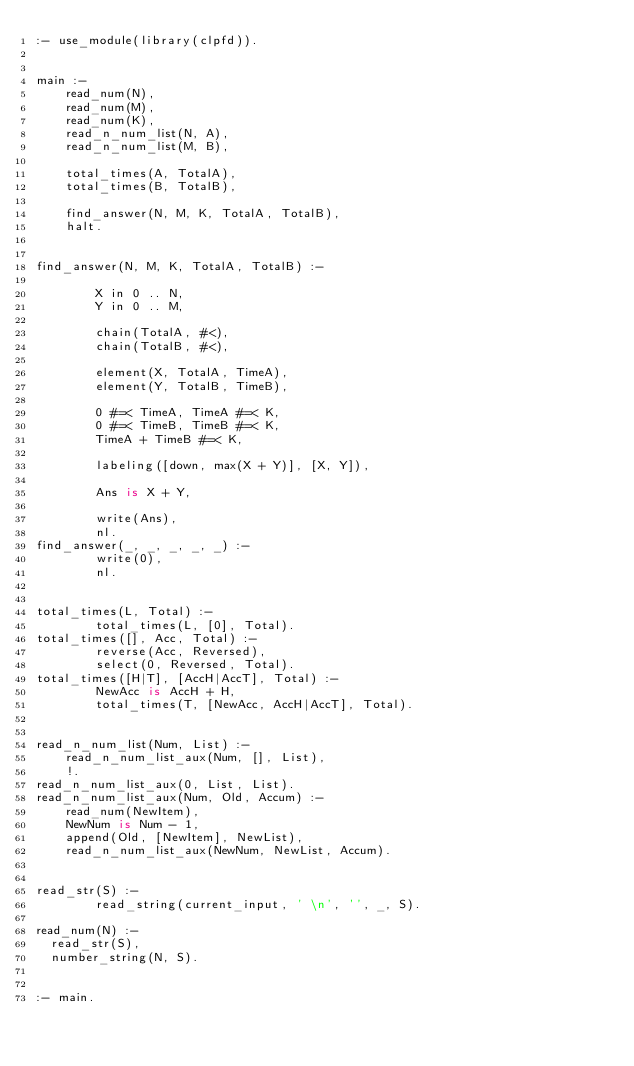<code> <loc_0><loc_0><loc_500><loc_500><_Prolog_>:- use_module(library(clpfd)).


main :-
    read_num(N),
    read_num(M),
    read_num(K),
    read_n_num_list(N, A),
    read_n_num_list(M, B),

    total_times(A, TotalA),
    total_times(B, TotalB),

    find_answer(N, M, K, TotalA, TotalB),
    halt.


find_answer(N, M, K, TotalA, TotalB) :-

        X in 0 .. N,
        Y in 0 .. M,

        chain(TotalA, #<),
        chain(TotalB, #<),
        
        element(X, TotalA, TimeA),
        element(Y, TotalB, TimeB),
        
        0 #=< TimeA, TimeA #=< K,
        0 #=< TimeB, TimeB #=< K,
        TimeA + TimeB #=< K,

        labeling([down, max(X + Y)], [X, Y]),

        Ans is X + Y,

        write(Ans),
        nl.
find_answer(_, _, _, _, _) :-
        write(0),
        nl.


total_times(L, Total) :-
        total_times(L, [0], Total).
total_times([], Acc, Total) :-
        reverse(Acc, Reversed),
        select(0, Reversed, Total).
total_times([H|T], [AccH|AccT], Total) :-
        NewAcc is AccH + H,
        total_times(T, [NewAcc, AccH|AccT], Total).


read_n_num_list(Num, List) :-
    read_n_num_list_aux(Num, [], List),
    !.
read_n_num_list_aux(0, List, List).
read_n_num_list_aux(Num, Old, Accum) :-
    read_num(NewItem),
    NewNum is Num - 1,
    append(Old, [NewItem], NewList),
    read_n_num_list_aux(NewNum, NewList, Accum).


read_str(S) :-
        read_string(current_input, ' \n', '', _, S).
 
read_num(N) :-
	read_str(S),
	number_string(N, S).


:- main.
</code> 